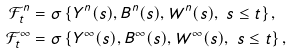Convert formula to latex. <formula><loc_0><loc_0><loc_500><loc_500>\mathcal { F } _ { t } ^ { n } & = \sigma \left \{ Y ^ { n } ( s ) , B ^ { n } ( s ) , W ^ { n } ( s ) , \text { } s \leq t \right \} , \\ \mathcal { F } _ { t } ^ { \infty } & = \sigma \left \{ Y ^ { \infty } ( s ) , B ^ { \infty } ( s ) , W ^ { \infty } ( s ) , \text { } s \leq t \right \} ,</formula> 